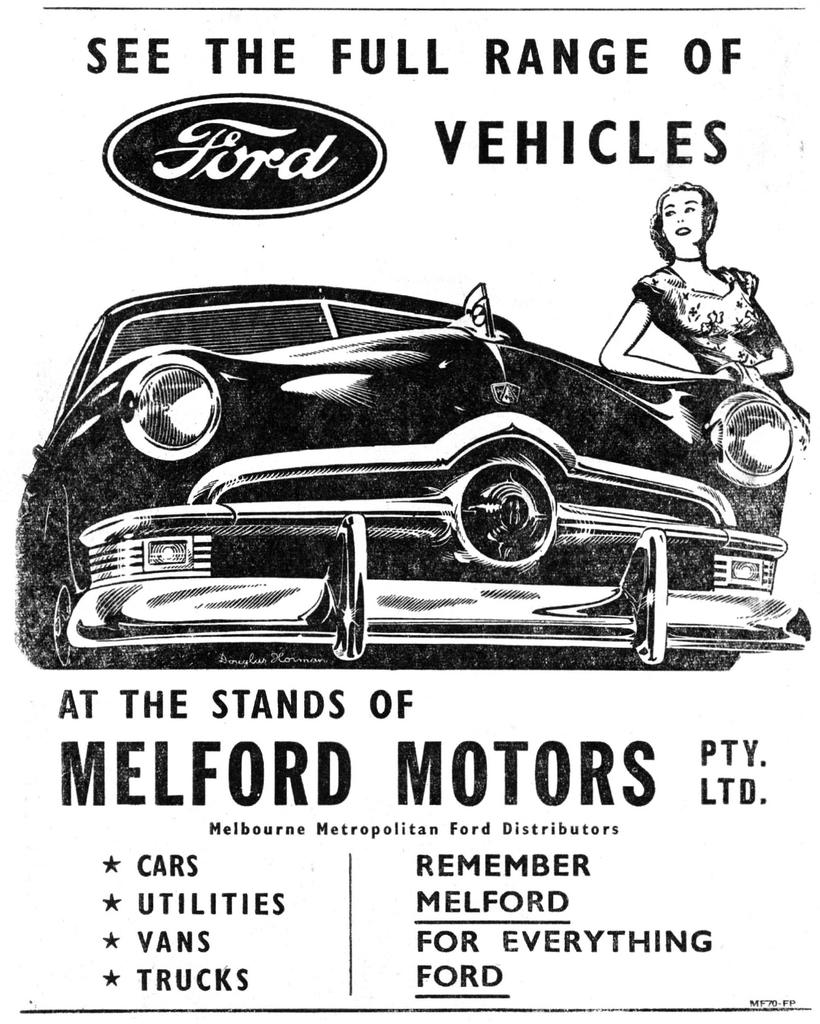What is the color scheme of the poster in the image? The poster is black and white. What is the main image depicted on the poster? There is a car in the poster. Who is standing beside the car in the poster? There is a lady beside the car in the poster. What text can be seen above and below the car in the poster? There is text written above the car and below the car in the poster. What type of shirt is the grandmother wearing in the image? There is no grandmother present in the image, and therefore no shirt to describe. Can you tell me how many chess pieces are visible on the car in the image? There are no chess pieces visible on the car in the image; it features a lady standing beside a car with text above and below it. 